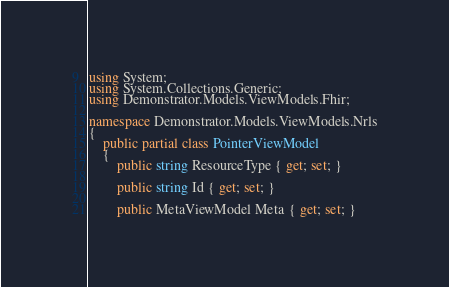<code> <loc_0><loc_0><loc_500><loc_500><_C#_>using System;
using System.Collections.Generic;
using Demonstrator.Models.ViewModels.Fhir;

namespace Demonstrator.Models.ViewModels.Nrls
{
    public partial class PointerViewModel
    {
        public string ResourceType { get; set; }

        public string Id { get; set; }

        public MetaViewModel Meta { get; set; }
</code> 